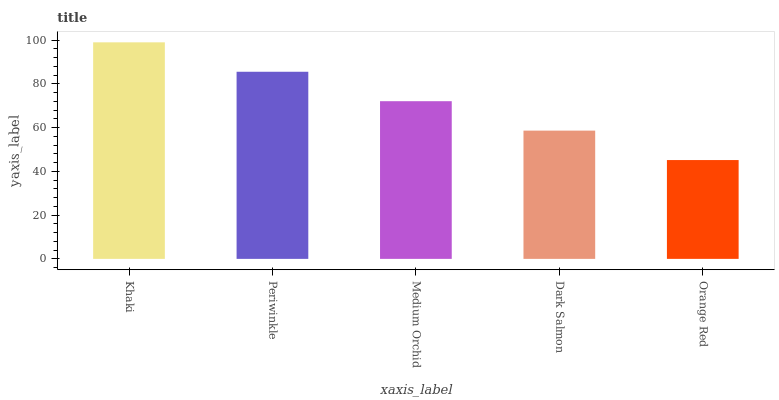Is Orange Red the minimum?
Answer yes or no. Yes. Is Khaki the maximum?
Answer yes or no. Yes. Is Periwinkle the minimum?
Answer yes or no. No. Is Periwinkle the maximum?
Answer yes or no. No. Is Khaki greater than Periwinkle?
Answer yes or no. Yes. Is Periwinkle less than Khaki?
Answer yes or no. Yes. Is Periwinkle greater than Khaki?
Answer yes or no. No. Is Khaki less than Periwinkle?
Answer yes or no. No. Is Medium Orchid the high median?
Answer yes or no. Yes. Is Medium Orchid the low median?
Answer yes or no. Yes. Is Orange Red the high median?
Answer yes or no. No. Is Orange Red the low median?
Answer yes or no. No. 